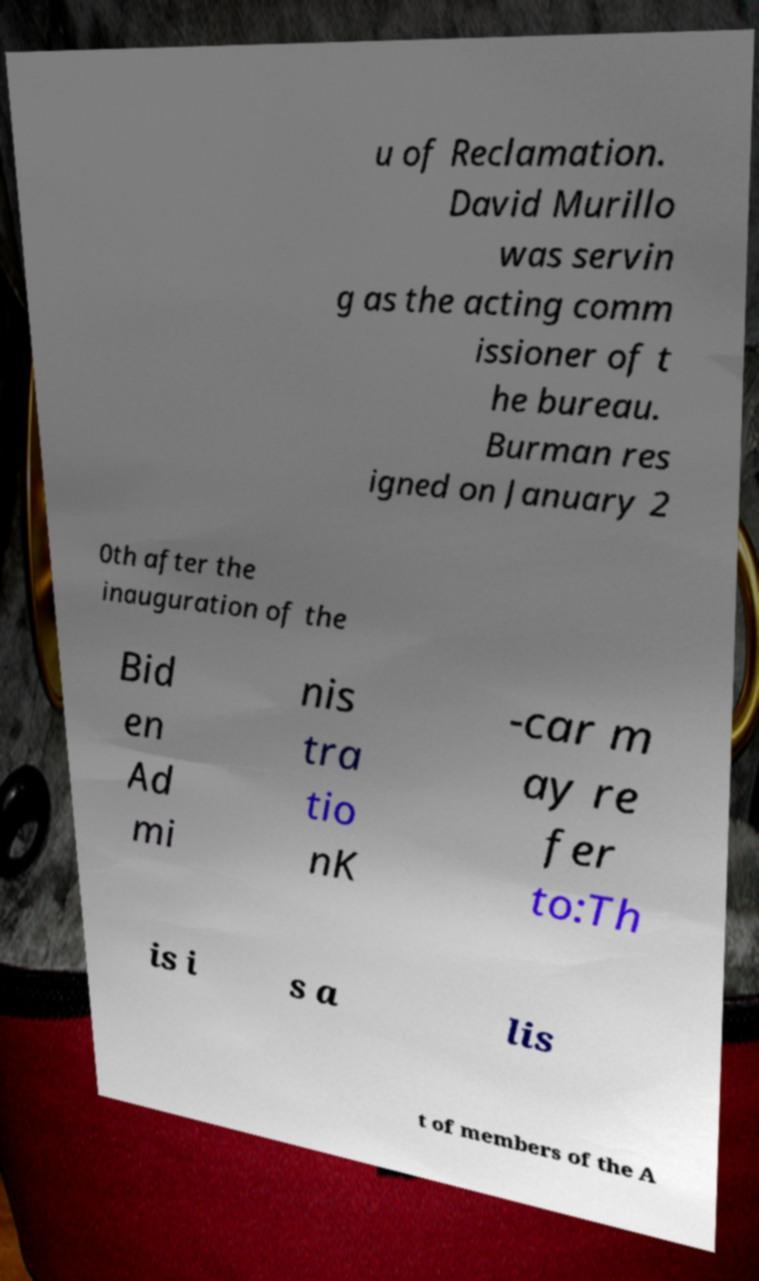There's text embedded in this image that I need extracted. Can you transcribe it verbatim? u of Reclamation. David Murillo was servin g as the acting comm issioner of t he bureau. Burman res igned on January 2 0th after the inauguration of the Bid en Ad mi nis tra tio nK -car m ay re fer to:Th is i s a lis t of members of the A 